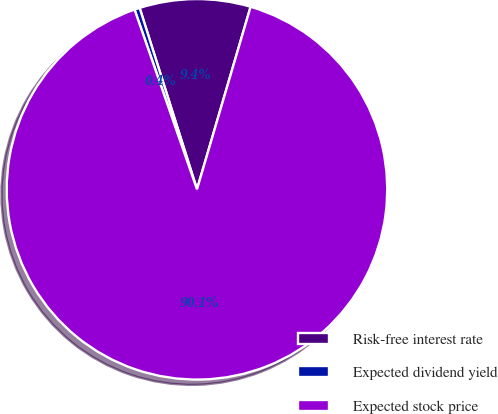Convert chart to OTSL. <chart><loc_0><loc_0><loc_500><loc_500><pie_chart><fcel>Risk-free interest rate<fcel>Expected dividend yield<fcel>Expected stock price<nl><fcel>9.42%<fcel>0.45%<fcel>90.13%<nl></chart> 